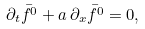<formula> <loc_0><loc_0><loc_500><loc_500>\partial _ { t } \bar { f ^ { 0 } } + a \, \partial _ { x } \bar { f ^ { 0 } } = 0 ,</formula> 